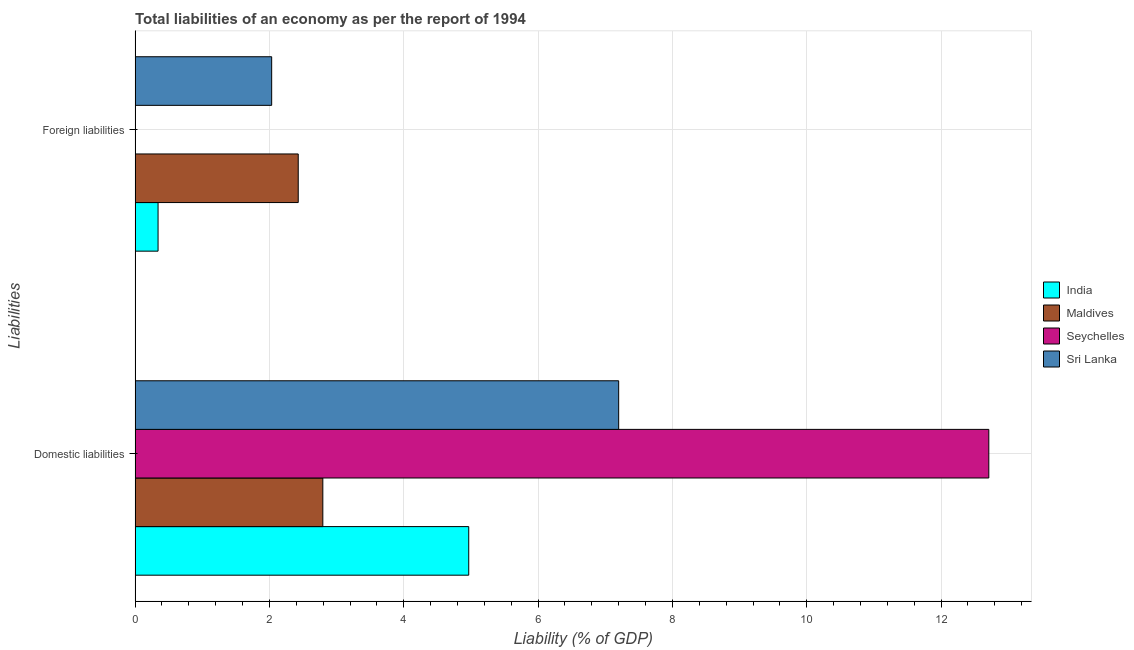What is the label of the 1st group of bars from the top?
Your response must be concise. Foreign liabilities. What is the incurrence of foreign liabilities in Maldives?
Give a very brief answer. 2.43. Across all countries, what is the maximum incurrence of domestic liabilities?
Make the answer very short. 12.71. Across all countries, what is the minimum incurrence of foreign liabilities?
Your response must be concise. 0. In which country was the incurrence of domestic liabilities maximum?
Provide a succinct answer. Seychelles. What is the total incurrence of foreign liabilities in the graph?
Your response must be concise. 4.81. What is the difference between the incurrence of domestic liabilities in Maldives and that in India?
Offer a terse response. -2.17. What is the difference between the incurrence of domestic liabilities in Seychelles and the incurrence of foreign liabilities in Maldives?
Your answer should be compact. 10.28. What is the average incurrence of domestic liabilities per country?
Keep it short and to the point. 6.92. What is the difference between the incurrence of foreign liabilities and incurrence of domestic liabilities in Sri Lanka?
Provide a short and direct response. -5.17. In how many countries, is the incurrence of domestic liabilities greater than 4 %?
Your response must be concise. 3. What is the ratio of the incurrence of foreign liabilities in India to that in Maldives?
Your answer should be very brief. 0.14. Is the incurrence of foreign liabilities in Sri Lanka less than that in India?
Offer a terse response. No. Are all the bars in the graph horizontal?
Ensure brevity in your answer.  Yes. How many countries are there in the graph?
Your response must be concise. 4. Does the graph contain any zero values?
Offer a terse response. Yes. How many legend labels are there?
Offer a very short reply. 4. What is the title of the graph?
Your answer should be very brief. Total liabilities of an economy as per the report of 1994. Does "Azerbaijan" appear as one of the legend labels in the graph?
Ensure brevity in your answer.  No. What is the label or title of the X-axis?
Offer a terse response. Liability (% of GDP). What is the label or title of the Y-axis?
Your answer should be compact. Liabilities. What is the Liability (% of GDP) in India in Domestic liabilities?
Ensure brevity in your answer.  4.97. What is the Liability (% of GDP) in Maldives in Domestic liabilities?
Provide a succinct answer. 2.8. What is the Liability (% of GDP) in Seychelles in Domestic liabilities?
Provide a succinct answer. 12.71. What is the Liability (% of GDP) in Sri Lanka in Domestic liabilities?
Your answer should be very brief. 7.2. What is the Liability (% of GDP) of India in Foreign liabilities?
Provide a short and direct response. 0.34. What is the Liability (% of GDP) of Maldives in Foreign liabilities?
Provide a succinct answer. 2.43. What is the Liability (% of GDP) in Sri Lanka in Foreign liabilities?
Provide a succinct answer. 2.03. Across all Liabilities, what is the maximum Liability (% of GDP) in India?
Ensure brevity in your answer.  4.97. Across all Liabilities, what is the maximum Liability (% of GDP) in Maldives?
Your response must be concise. 2.8. Across all Liabilities, what is the maximum Liability (% of GDP) in Seychelles?
Your answer should be very brief. 12.71. Across all Liabilities, what is the maximum Liability (% of GDP) of Sri Lanka?
Make the answer very short. 7.2. Across all Liabilities, what is the minimum Liability (% of GDP) of India?
Your answer should be very brief. 0.34. Across all Liabilities, what is the minimum Liability (% of GDP) in Maldives?
Provide a short and direct response. 2.43. Across all Liabilities, what is the minimum Liability (% of GDP) in Sri Lanka?
Give a very brief answer. 2.03. What is the total Liability (% of GDP) of India in the graph?
Your answer should be very brief. 5.31. What is the total Liability (% of GDP) in Maldives in the graph?
Make the answer very short. 5.22. What is the total Liability (% of GDP) of Seychelles in the graph?
Make the answer very short. 12.71. What is the total Liability (% of GDP) of Sri Lanka in the graph?
Keep it short and to the point. 9.23. What is the difference between the Liability (% of GDP) in India in Domestic liabilities and that in Foreign liabilities?
Ensure brevity in your answer.  4.63. What is the difference between the Liability (% of GDP) of Maldives in Domestic liabilities and that in Foreign liabilities?
Offer a very short reply. 0.37. What is the difference between the Liability (% of GDP) of Sri Lanka in Domestic liabilities and that in Foreign liabilities?
Your answer should be compact. 5.17. What is the difference between the Liability (% of GDP) of India in Domestic liabilities and the Liability (% of GDP) of Maldives in Foreign liabilities?
Give a very brief answer. 2.54. What is the difference between the Liability (% of GDP) in India in Domestic liabilities and the Liability (% of GDP) in Sri Lanka in Foreign liabilities?
Make the answer very short. 2.93. What is the difference between the Liability (% of GDP) in Maldives in Domestic liabilities and the Liability (% of GDP) in Sri Lanka in Foreign liabilities?
Provide a short and direct response. 0.76. What is the difference between the Liability (% of GDP) of Seychelles in Domestic liabilities and the Liability (% of GDP) of Sri Lanka in Foreign liabilities?
Provide a short and direct response. 10.68. What is the average Liability (% of GDP) in India per Liabilities?
Make the answer very short. 2.66. What is the average Liability (% of GDP) of Maldives per Liabilities?
Offer a very short reply. 2.61. What is the average Liability (% of GDP) of Seychelles per Liabilities?
Make the answer very short. 6.36. What is the average Liability (% of GDP) of Sri Lanka per Liabilities?
Provide a succinct answer. 4.62. What is the difference between the Liability (% of GDP) in India and Liability (% of GDP) in Maldives in Domestic liabilities?
Provide a succinct answer. 2.17. What is the difference between the Liability (% of GDP) in India and Liability (% of GDP) in Seychelles in Domestic liabilities?
Your answer should be very brief. -7.74. What is the difference between the Liability (% of GDP) of India and Liability (% of GDP) of Sri Lanka in Domestic liabilities?
Ensure brevity in your answer.  -2.23. What is the difference between the Liability (% of GDP) of Maldives and Liability (% of GDP) of Seychelles in Domestic liabilities?
Provide a short and direct response. -9.92. What is the difference between the Liability (% of GDP) of Maldives and Liability (% of GDP) of Sri Lanka in Domestic liabilities?
Keep it short and to the point. -4.4. What is the difference between the Liability (% of GDP) in Seychelles and Liability (% of GDP) in Sri Lanka in Domestic liabilities?
Offer a terse response. 5.51. What is the difference between the Liability (% of GDP) of India and Liability (% of GDP) of Maldives in Foreign liabilities?
Give a very brief answer. -2.09. What is the difference between the Liability (% of GDP) in India and Liability (% of GDP) in Sri Lanka in Foreign liabilities?
Your answer should be compact. -1.69. What is the difference between the Liability (% of GDP) in Maldives and Liability (% of GDP) in Sri Lanka in Foreign liabilities?
Give a very brief answer. 0.4. What is the ratio of the Liability (% of GDP) of India in Domestic liabilities to that in Foreign liabilities?
Make the answer very short. 14.51. What is the ratio of the Liability (% of GDP) of Maldives in Domestic liabilities to that in Foreign liabilities?
Make the answer very short. 1.15. What is the ratio of the Liability (% of GDP) in Sri Lanka in Domestic liabilities to that in Foreign liabilities?
Offer a terse response. 3.54. What is the difference between the highest and the second highest Liability (% of GDP) of India?
Provide a short and direct response. 4.63. What is the difference between the highest and the second highest Liability (% of GDP) of Maldives?
Provide a succinct answer. 0.37. What is the difference between the highest and the second highest Liability (% of GDP) of Sri Lanka?
Offer a very short reply. 5.17. What is the difference between the highest and the lowest Liability (% of GDP) of India?
Provide a succinct answer. 4.63. What is the difference between the highest and the lowest Liability (% of GDP) in Maldives?
Offer a very short reply. 0.37. What is the difference between the highest and the lowest Liability (% of GDP) in Seychelles?
Give a very brief answer. 12.71. What is the difference between the highest and the lowest Liability (% of GDP) of Sri Lanka?
Provide a succinct answer. 5.17. 